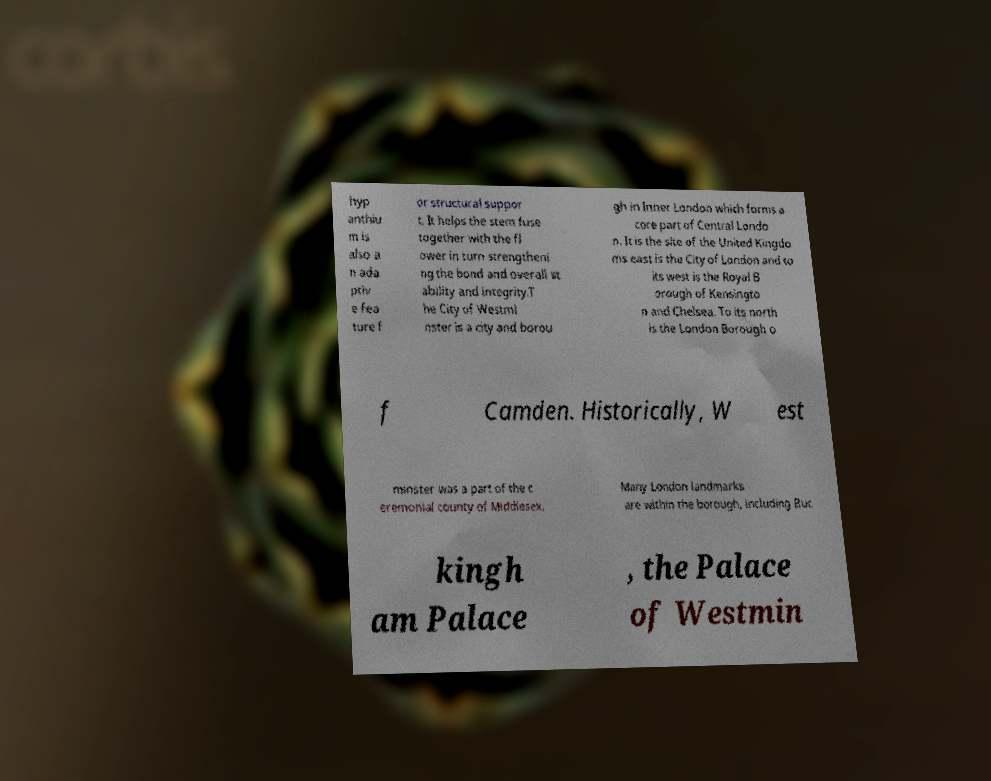Can you read and provide the text displayed in the image?This photo seems to have some interesting text. Can you extract and type it out for me? hyp anthiu m is also a n ada ptiv e fea ture f or structural suppor t. It helps the stem fuse together with the fl ower in turn strengtheni ng the bond and overall st ability and integrity.T he City of Westmi nster is a city and borou gh in Inner London which forms a core part of Central Londo n. It is the site of the United Kingdo ms east is the City of London and to its west is the Royal B orough of Kensingto n and Chelsea. To its north is the London Borough o f Camden. Historically, W est minster was a part of the c eremonial county of Middlesex. Many London landmarks are within the borough, including Buc kingh am Palace , the Palace of Westmin 